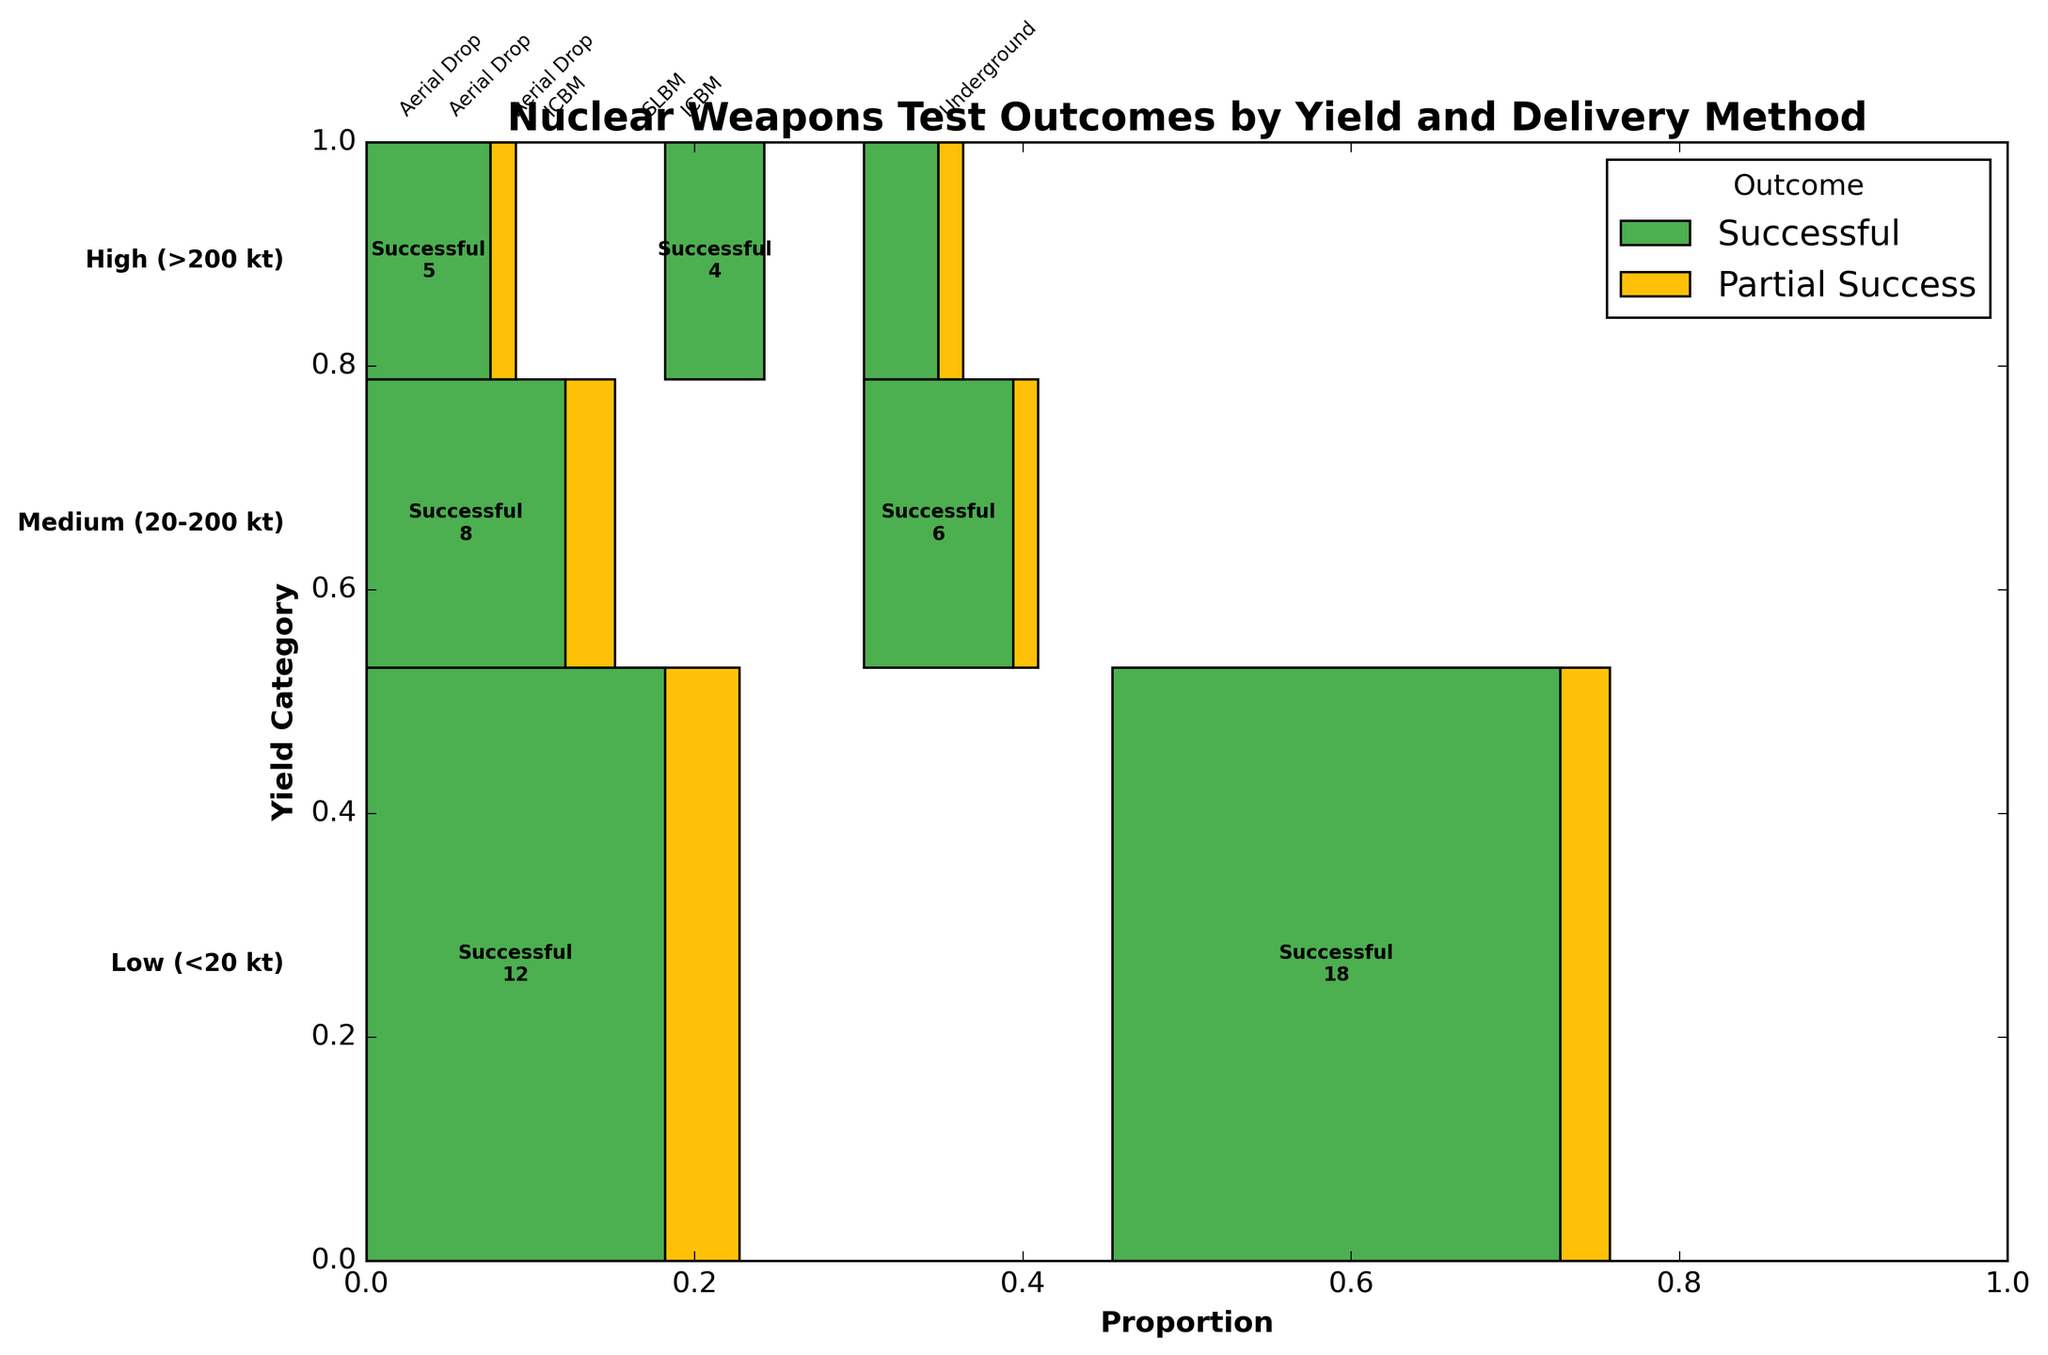What are the color representations in the mosaic plot? The plot uses distinct colors to represent outcomes: green for "Successful" and yellow for "Partial Success". This helps in easily differentiating between the outcomes of the nuclear tests.
Answer: Green for Successful, Yellow for Partial Success Which delivery method for Medium yield (20-200 kt) nuclear weapons had the fewest successful tests? To determine this, we look at the Medium yield section and compare the proportion of successful tests for each delivery method. ICBM had fewer successful tests compared to Aerial Drop.
Answer: ICBM How many partial successes were recorded for High yield (>200 kt) tests delivered via SLBM? We locate the section for High yield and within that, the portion for SLBM. From the figure, we identify the count text within this section indicating "Partial Success". The count is 1.
Answer: 1 What is the total number of successful tests for Low yield (<20 kt) nuclear weapons? We sum up the counts for the Success outcomes in the Low yield category across all delivery methods: 12 (Aerial Drop) + 18 (Underground).
Answer: 30 Between Aerial Drop and Underground delivery methods for Low yield tests, which had a higher percentage of successful outcomes? By comparing the sections in the Low yield category, we see that Underground has a wider successful outcomes section compared to Aerial Drop. Therefore, Underground has a higher percentage.
Answer: Underground Which yield category had the highest overall proportion in the plot? The plot's vertical sections represent yield categories, where their height indicates their proportion. The Low yield section is the largest.
Answer: Low yield What percentage of Medium yield tests delivered via ICBM were partially successful? For Medium yield and ICBM, we look at the portion labeled "Partial Success" within the segment and compare its width to the entire Medium yield ICBM segment. The partial success proportion is 1 out of the total 7 tests.
Answer: ~14.3% How do successful and partial success outcomes compare for High yield tests delivered via Aerial Drop? In the High yield category for Aerial Drop, visually compare the green section (successful) and yellow section (partial success). The number of successful tests is significantly higher than partial successes (5 vs. 1).
Answer: Successful outcomes are higher Which delivery method has the highest variability in test outcomes for Medium yield (20-200 kt) nuclear weapons? By inspecting the segments for Medium yield, we note that Aerial Drop and ICBM have both success and partial success outcomes, but Aerial Drop has larger proportional differences between outcomes.
Answer: Aerial Drop Is there any yield category and delivery method that did not achieve any partial success? Examine the plot for segments that lack yellow sections. Both Underground for Low yield and High yield for ICBM do not have any partial success outcomes.
Answer: Yes, several combinations such as Underground for Low yield and ICBM for High yield 